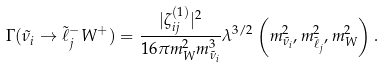<formula> <loc_0><loc_0><loc_500><loc_500>\Gamma ( \tilde { \nu } _ { i } \to \tilde { \ell } _ { j } ^ { - } W ^ { + } ) = \frac { | \zeta _ { i j } ^ { ( 1 ) } | ^ { 2 } } { 1 6 \pi m _ { W } ^ { 2 } m _ { \tilde { \nu } _ { i } } ^ { 3 } } \lambda ^ { 3 / 2 } \left ( m _ { \tilde { \nu } _ { i } } ^ { 2 } , m _ { \tilde { \ell } _ { j } } ^ { 2 } , m _ { W } ^ { 2 } \right ) .</formula> 